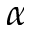Convert formula to latex. <formula><loc_0><loc_0><loc_500><loc_500>\alpha</formula> 